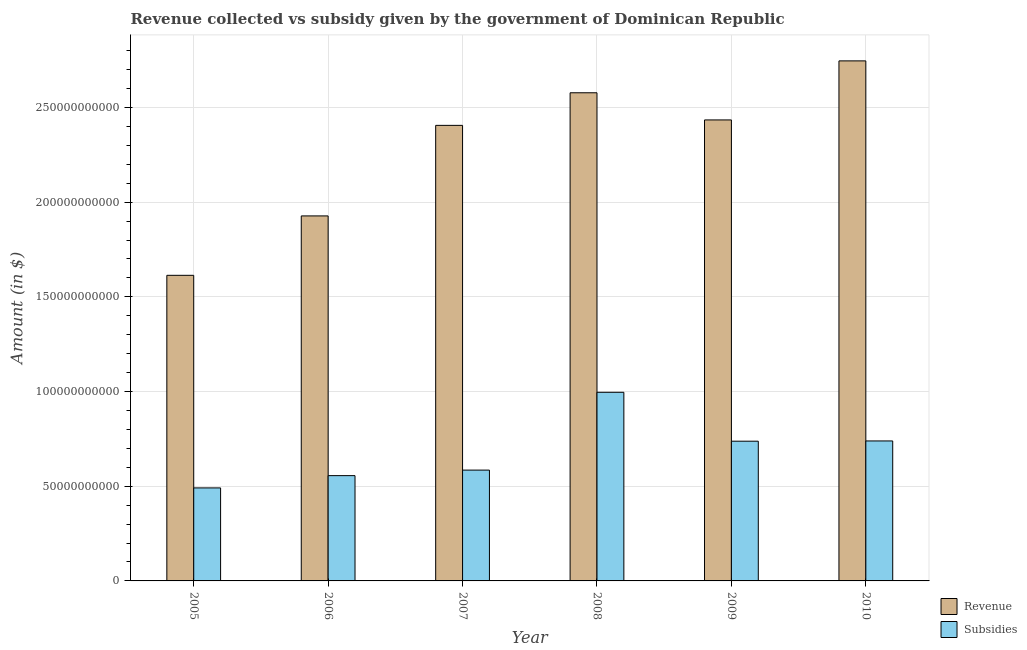Are the number of bars per tick equal to the number of legend labels?
Give a very brief answer. Yes. How many bars are there on the 4th tick from the left?
Offer a very short reply. 2. How many bars are there on the 2nd tick from the right?
Give a very brief answer. 2. What is the amount of revenue collected in 2008?
Provide a short and direct response. 2.58e+11. Across all years, what is the maximum amount of subsidies given?
Offer a terse response. 9.96e+1. Across all years, what is the minimum amount of subsidies given?
Offer a terse response. 4.91e+1. In which year was the amount of revenue collected minimum?
Offer a very short reply. 2005. What is the total amount of subsidies given in the graph?
Ensure brevity in your answer.  4.11e+11. What is the difference between the amount of revenue collected in 2008 and that in 2009?
Your response must be concise. 1.43e+1. What is the difference between the amount of revenue collected in 2005 and the amount of subsidies given in 2010?
Your answer should be very brief. -1.13e+11. What is the average amount of revenue collected per year?
Give a very brief answer. 2.28e+11. What is the ratio of the amount of subsidies given in 2005 to that in 2009?
Offer a terse response. 0.67. What is the difference between the highest and the second highest amount of revenue collected?
Make the answer very short. 1.68e+1. What is the difference between the highest and the lowest amount of revenue collected?
Your answer should be very brief. 1.13e+11. What does the 1st bar from the left in 2005 represents?
Offer a very short reply. Revenue. What does the 1st bar from the right in 2009 represents?
Offer a very short reply. Subsidies. How many bars are there?
Your response must be concise. 12. Does the graph contain any zero values?
Keep it short and to the point. No. Does the graph contain grids?
Provide a succinct answer. Yes. Where does the legend appear in the graph?
Offer a terse response. Bottom right. How are the legend labels stacked?
Offer a very short reply. Vertical. What is the title of the graph?
Provide a succinct answer. Revenue collected vs subsidy given by the government of Dominican Republic. What is the label or title of the Y-axis?
Offer a very short reply. Amount (in $). What is the Amount (in $) in Revenue in 2005?
Your response must be concise. 1.61e+11. What is the Amount (in $) in Subsidies in 2005?
Your response must be concise. 4.91e+1. What is the Amount (in $) of Revenue in 2006?
Your answer should be compact. 1.93e+11. What is the Amount (in $) of Subsidies in 2006?
Your answer should be compact. 5.56e+1. What is the Amount (in $) of Revenue in 2007?
Your response must be concise. 2.41e+11. What is the Amount (in $) in Subsidies in 2007?
Your response must be concise. 5.85e+1. What is the Amount (in $) in Revenue in 2008?
Give a very brief answer. 2.58e+11. What is the Amount (in $) of Subsidies in 2008?
Make the answer very short. 9.96e+1. What is the Amount (in $) in Revenue in 2009?
Give a very brief answer. 2.43e+11. What is the Amount (in $) of Subsidies in 2009?
Give a very brief answer. 7.38e+1. What is the Amount (in $) in Revenue in 2010?
Your answer should be very brief. 2.75e+11. What is the Amount (in $) in Subsidies in 2010?
Ensure brevity in your answer.  7.39e+1. Across all years, what is the maximum Amount (in $) in Revenue?
Make the answer very short. 2.75e+11. Across all years, what is the maximum Amount (in $) of Subsidies?
Your answer should be very brief. 9.96e+1. Across all years, what is the minimum Amount (in $) of Revenue?
Your answer should be compact. 1.61e+11. Across all years, what is the minimum Amount (in $) in Subsidies?
Your answer should be very brief. 4.91e+1. What is the total Amount (in $) in Revenue in the graph?
Offer a terse response. 1.37e+12. What is the total Amount (in $) in Subsidies in the graph?
Your response must be concise. 4.11e+11. What is the difference between the Amount (in $) in Revenue in 2005 and that in 2006?
Your response must be concise. -3.14e+1. What is the difference between the Amount (in $) in Subsidies in 2005 and that in 2006?
Provide a succinct answer. -6.48e+09. What is the difference between the Amount (in $) of Revenue in 2005 and that in 2007?
Keep it short and to the point. -7.92e+1. What is the difference between the Amount (in $) in Subsidies in 2005 and that in 2007?
Provide a short and direct response. -9.40e+09. What is the difference between the Amount (in $) of Revenue in 2005 and that in 2008?
Your answer should be compact. -9.64e+1. What is the difference between the Amount (in $) of Subsidies in 2005 and that in 2008?
Give a very brief answer. -5.05e+1. What is the difference between the Amount (in $) of Revenue in 2005 and that in 2009?
Your answer should be very brief. -8.21e+1. What is the difference between the Amount (in $) in Subsidies in 2005 and that in 2009?
Offer a terse response. -2.47e+1. What is the difference between the Amount (in $) of Revenue in 2005 and that in 2010?
Your answer should be compact. -1.13e+11. What is the difference between the Amount (in $) in Subsidies in 2005 and that in 2010?
Give a very brief answer. -2.48e+1. What is the difference between the Amount (in $) in Revenue in 2006 and that in 2007?
Provide a succinct answer. -4.78e+1. What is the difference between the Amount (in $) in Subsidies in 2006 and that in 2007?
Keep it short and to the point. -2.92e+09. What is the difference between the Amount (in $) in Revenue in 2006 and that in 2008?
Keep it short and to the point. -6.50e+1. What is the difference between the Amount (in $) of Subsidies in 2006 and that in 2008?
Your answer should be very brief. -4.40e+1. What is the difference between the Amount (in $) of Revenue in 2006 and that in 2009?
Your answer should be compact. -5.07e+1. What is the difference between the Amount (in $) of Subsidies in 2006 and that in 2009?
Provide a short and direct response. -1.82e+1. What is the difference between the Amount (in $) of Revenue in 2006 and that in 2010?
Offer a very short reply. -8.19e+1. What is the difference between the Amount (in $) of Subsidies in 2006 and that in 2010?
Your answer should be compact. -1.83e+1. What is the difference between the Amount (in $) in Revenue in 2007 and that in 2008?
Offer a very short reply. -1.72e+1. What is the difference between the Amount (in $) of Subsidies in 2007 and that in 2008?
Offer a terse response. -4.11e+1. What is the difference between the Amount (in $) in Revenue in 2007 and that in 2009?
Your answer should be compact. -2.87e+09. What is the difference between the Amount (in $) of Subsidies in 2007 and that in 2009?
Your answer should be compact. -1.53e+1. What is the difference between the Amount (in $) of Revenue in 2007 and that in 2010?
Provide a short and direct response. -3.41e+1. What is the difference between the Amount (in $) in Subsidies in 2007 and that in 2010?
Offer a terse response. -1.54e+1. What is the difference between the Amount (in $) of Revenue in 2008 and that in 2009?
Ensure brevity in your answer.  1.43e+1. What is the difference between the Amount (in $) of Subsidies in 2008 and that in 2009?
Provide a short and direct response. 2.58e+1. What is the difference between the Amount (in $) in Revenue in 2008 and that in 2010?
Offer a very short reply. -1.68e+1. What is the difference between the Amount (in $) of Subsidies in 2008 and that in 2010?
Offer a terse response. 2.57e+1. What is the difference between the Amount (in $) in Revenue in 2009 and that in 2010?
Ensure brevity in your answer.  -3.12e+1. What is the difference between the Amount (in $) in Subsidies in 2009 and that in 2010?
Your response must be concise. -1.29e+08. What is the difference between the Amount (in $) of Revenue in 2005 and the Amount (in $) of Subsidies in 2006?
Ensure brevity in your answer.  1.06e+11. What is the difference between the Amount (in $) in Revenue in 2005 and the Amount (in $) in Subsidies in 2007?
Give a very brief answer. 1.03e+11. What is the difference between the Amount (in $) of Revenue in 2005 and the Amount (in $) of Subsidies in 2008?
Provide a short and direct response. 6.18e+1. What is the difference between the Amount (in $) of Revenue in 2005 and the Amount (in $) of Subsidies in 2009?
Ensure brevity in your answer.  8.76e+1. What is the difference between the Amount (in $) in Revenue in 2005 and the Amount (in $) in Subsidies in 2010?
Keep it short and to the point. 8.75e+1. What is the difference between the Amount (in $) in Revenue in 2006 and the Amount (in $) in Subsidies in 2007?
Ensure brevity in your answer.  1.34e+11. What is the difference between the Amount (in $) in Revenue in 2006 and the Amount (in $) in Subsidies in 2008?
Offer a terse response. 9.31e+1. What is the difference between the Amount (in $) in Revenue in 2006 and the Amount (in $) in Subsidies in 2009?
Your answer should be compact. 1.19e+11. What is the difference between the Amount (in $) in Revenue in 2006 and the Amount (in $) in Subsidies in 2010?
Make the answer very short. 1.19e+11. What is the difference between the Amount (in $) in Revenue in 2007 and the Amount (in $) in Subsidies in 2008?
Your answer should be very brief. 1.41e+11. What is the difference between the Amount (in $) in Revenue in 2007 and the Amount (in $) in Subsidies in 2009?
Your response must be concise. 1.67e+11. What is the difference between the Amount (in $) in Revenue in 2007 and the Amount (in $) in Subsidies in 2010?
Keep it short and to the point. 1.67e+11. What is the difference between the Amount (in $) in Revenue in 2008 and the Amount (in $) in Subsidies in 2009?
Offer a terse response. 1.84e+11. What is the difference between the Amount (in $) in Revenue in 2008 and the Amount (in $) in Subsidies in 2010?
Make the answer very short. 1.84e+11. What is the difference between the Amount (in $) of Revenue in 2009 and the Amount (in $) of Subsidies in 2010?
Provide a succinct answer. 1.70e+11. What is the average Amount (in $) of Revenue per year?
Provide a succinct answer. 2.28e+11. What is the average Amount (in $) in Subsidies per year?
Offer a terse response. 6.84e+1. In the year 2005, what is the difference between the Amount (in $) of Revenue and Amount (in $) of Subsidies?
Your response must be concise. 1.12e+11. In the year 2006, what is the difference between the Amount (in $) in Revenue and Amount (in $) in Subsidies?
Provide a succinct answer. 1.37e+11. In the year 2007, what is the difference between the Amount (in $) in Revenue and Amount (in $) in Subsidies?
Keep it short and to the point. 1.82e+11. In the year 2008, what is the difference between the Amount (in $) of Revenue and Amount (in $) of Subsidies?
Your answer should be very brief. 1.58e+11. In the year 2009, what is the difference between the Amount (in $) in Revenue and Amount (in $) in Subsidies?
Give a very brief answer. 1.70e+11. In the year 2010, what is the difference between the Amount (in $) of Revenue and Amount (in $) of Subsidies?
Offer a very short reply. 2.01e+11. What is the ratio of the Amount (in $) of Revenue in 2005 to that in 2006?
Give a very brief answer. 0.84. What is the ratio of the Amount (in $) of Subsidies in 2005 to that in 2006?
Give a very brief answer. 0.88. What is the ratio of the Amount (in $) in Revenue in 2005 to that in 2007?
Keep it short and to the point. 0.67. What is the ratio of the Amount (in $) in Subsidies in 2005 to that in 2007?
Provide a short and direct response. 0.84. What is the ratio of the Amount (in $) in Revenue in 2005 to that in 2008?
Your answer should be compact. 0.63. What is the ratio of the Amount (in $) of Subsidies in 2005 to that in 2008?
Your answer should be very brief. 0.49. What is the ratio of the Amount (in $) in Revenue in 2005 to that in 2009?
Provide a succinct answer. 0.66. What is the ratio of the Amount (in $) of Subsidies in 2005 to that in 2009?
Give a very brief answer. 0.67. What is the ratio of the Amount (in $) in Revenue in 2005 to that in 2010?
Your answer should be compact. 0.59. What is the ratio of the Amount (in $) in Subsidies in 2005 to that in 2010?
Offer a terse response. 0.66. What is the ratio of the Amount (in $) in Revenue in 2006 to that in 2007?
Offer a very short reply. 0.8. What is the ratio of the Amount (in $) in Subsidies in 2006 to that in 2007?
Offer a terse response. 0.95. What is the ratio of the Amount (in $) in Revenue in 2006 to that in 2008?
Provide a short and direct response. 0.75. What is the ratio of the Amount (in $) in Subsidies in 2006 to that in 2008?
Provide a succinct answer. 0.56. What is the ratio of the Amount (in $) of Revenue in 2006 to that in 2009?
Offer a very short reply. 0.79. What is the ratio of the Amount (in $) in Subsidies in 2006 to that in 2009?
Offer a terse response. 0.75. What is the ratio of the Amount (in $) in Revenue in 2006 to that in 2010?
Provide a short and direct response. 0.7. What is the ratio of the Amount (in $) of Subsidies in 2006 to that in 2010?
Provide a short and direct response. 0.75. What is the ratio of the Amount (in $) in Revenue in 2007 to that in 2008?
Offer a very short reply. 0.93. What is the ratio of the Amount (in $) in Subsidies in 2007 to that in 2008?
Offer a terse response. 0.59. What is the ratio of the Amount (in $) in Subsidies in 2007 to that in 2009?
Offer a very short reply. 0.79. What is the ratio of the Amount (in $) in Revenue in 2007 to that in 2010?
Your answer should be very brief. 0.88. What is the ratio of the Amount (in $) of Subsidies in 2007 to that in 2010?
Offer a very short reply. 0.79. What is the ratio of the Amount (in $) of Revenue in 2008 to that in 2009?
Keep it short and to the point. 1.06. What is the ratio of the Amount (in $) in Subsidies in 2008 to that in 2009?
Give a very brief answer. 1.35. What is the ratio of the Amount (in $) in Revenue in 2008 to that in 2010?
Provide a short and direct response. 0.94. What is the ratio of the Amount (in $) of Subsidies in 2008 to that in 2010?
Your answer should be compact. 1.35. What is the ratio of the Amount (in $) in Revenue in 2009 to that in 2010?
Make the answer very short. 0.89. What is the ratio of the Amount (in $) of Subsidies in 2009 to that in 2010?
Provide a succinct answer. 1. What is the difference between the highest and the second highest Amount (in $) in Revenue?
Provide a short and direct response. 1.68e+1. What is the difference between the highest and the second highest Amount (in $) in Subsidies?
Your response must be concise. 2.57e+1. What is the difference between the highest and the lowest Amount (in $) in Revenue?
Make the answer very short. 1.13e+11. What is the difference between the highest and the lowest Amount (in $) in Subsidies?
Make the answer very short. 5.05e+1. 